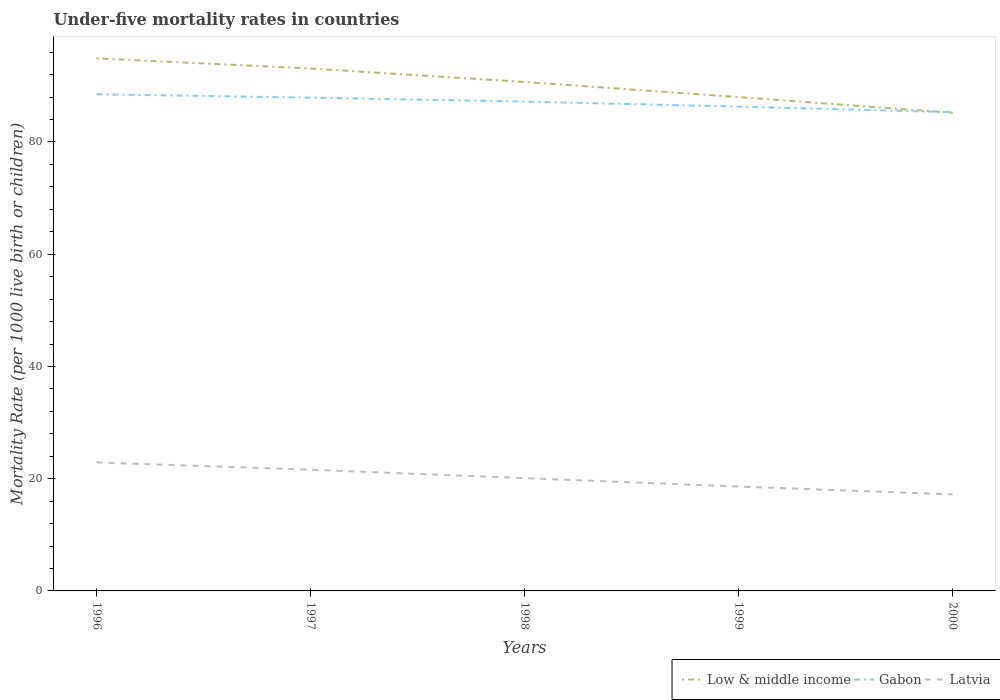Does the line corresponding to Low & middle income intersect with the line corresponding to Latvia?
Offer a terse response. No. Is the number of lines equal to the number of legend labels?
Your answer should be compact. Yes. Across all years, what is the maximum under-five mortality rate in Gabon?
Your answer should be very brief. 85.3. In which year was the under-five mortality rate in Low & middle income maximum?
Give a very brief answer. 2000. What is the total under-five mortality rate in Gabon in the graph?
Provide a short and direct response. 0.6. What is the difference between the highest and the second highest under-five mortality rate in Low & middle income?
Your answer should be compact. 9.7. What is the difference between the highest and the lowest under-five mortality rate in Gabon?
Provide a short and direct response. 3. Is the under-five mortality rate in Latvia strictly greater than the under-five mortality rate in Low & middle income over the years?
Keep it short and to the point. Yes. How many lines are there?
Your response must be concise. 3. How many years are there in the graph?
Offer a very short reply. 5. Does the graph contain any zero values?
Provide a short and direct response. No. Does the graph contain grids?
Your answer should be very brief. No. What is the title of the graph?
Your answer should be compact. Under-five mortality rates in countries. What is the label or title of the X-axis?
Make the answer very short. Years. What is the label or title of the Y-axis?
Provide a succinct answer. Mortality Rate (per 1000 live birth or children). What is the Mortality Rate (per 1000 live birth or children) of Low & middle income in 1996?
Your answer should be very brief. 94.9. What is the Mortality Rate (per 1000 live birth or children) of Gabon in 1996?
Provide a succinct answer. 88.5. What is the Mortality Rate (per 1000 live birth or children) of Latvia in 1996?
Make the answer very short. 22.9. What is the Mortality Rate (per 1000 live birth or children) in Low & middle income in 1997?
Provide a short and direct response. 93.1. What is the Mortality Rate (per 1000 live birth or children) of Gabon in 1997?
Your answer should be very brief. 87.9. What is the Mortality Rate (per 1000 live birth or children) of Latvia in 1997?
Ensure brevity in your answer.  21.6. What is the Mortality Rate (per 1000 live birth or children) of Low & middle income in 1998?
Ensure brevity in your answer.  90.7. What is the Mortality Rate (per 1000 live birth or children) in Gabon in 1998?
Offer a terse response. 87.2. What is the Mortality Rate (per 1000 live birth or children) in Latvia in 1998?
Provide a short and direct response. 20.1. What is the Mortality Rate (per 1000 live birth or children) of Gabon in 1999?
Provide a succinct answer. 86.3. What is the Mortality Rate (per 1000 live birth or children) of Latvia in 1999?
Offer a terse response. 18.6. What is the Mortality Rate (per 1000 live birth or children) of Low & middle income in 2000?
Your answer should be compact. 85.2. What is the Mortality Rate (per 1000 live birth or children) of Gabon in 2000?
Keep it short and to the point. 85.3. Across all years, what is the maximum Mortality Rate (per 1000 live birth or children) in Low & middle income?
Your answer should be compact. 94.9. Across all years, what is the maximum Mortality Rate (per 1000 live birth or children) of Gabon?
Keep it short and to the point. 88.5. Across all years, what is the maximum Mortality Rate (per 1000 live birth or children) in Latvia?
Your answer should be compact. 22.9. Across all years, what is the minimum Mortality Rate (per 1000 live birth or children) in Low & middle income?
Provide a succinct answer. 85.2. Across all years, what is the minimum Mortality Rate (per 1000 live birth or children) of Gabon?
Keep it short and to the point. 85.3. Across all years, what is the minimum Mortality Rate (per 1000 live birth or children) in Latvia?
Provide a short and direct response. 17.2. What is the total Mortality Rate (per 1000 live birth or children) of Low & middle income in the graph?
Provide a succinct answer. 451.9. What is the total Mortality Rate (per 1000 live birth or children) of Gabon in the graph?
Your answer should be very brief. 435.2. What is the total Mortality Rate (per 1000 live birth or children) of Latvia in the graph?
Your response must be concise. 100.4. What is the difference between the Mortality Rate (per 1000 live birth or children) in Low & middle income in 1996 and that in 1998?
Your response must be concise. 4.2. What is the difference between the Mortality Rate (per 1000 live birth or children) in Gabon in 1996 and that in 1998?
Offer a terse response. 1.3. What is the difference between the Mortality Rate (per 1000 live birth or children) of Low & middle income in 1996 and that in 1999?
Give a very brief answer. 6.9. What is the difference between the Mortality Rate (per 1000 live birth or children) of Gabon in 1996 and that in 1999?
Your answer should be very brief. 2.2. What is the difference between the Mortality Rate (per 1000 live birth or children) in Latvia in 1996 and that in 1999?
Your response must be concise. 4.3. What is the difference between the Mortality Rate (per 1000 live birth or children) in Low & middle income in 1996 and that in 2000?
Keep it short and to the point. 9.7. What is the difference between the Mortality Rate (per 1000 live birth or children) in Latvia in 1996 and that in 2000?
Your answer should be very brief. 5.7. What is the difference between the Mortality Rate (per 1000 live birth or children) in Low & middle income in 1997 and that in 1998?
Your answer should be compact. 2.4. What is the difference between the Mortality Rate (per 1000 live birth or children) in Gabon in 1997 and that in 1998?
Offer a very short reply. 0.7. What is the difference between the Mortality Rate (per 1000 live birth or children) in Latvia in 1997 and that in 1998?
Offer a very short reply. 1.5. What is the difference between the Mortality Rate (per 1000 live birth or children) in Latvia in 1997 and that in 1999?
Offer a very short reply. 3. What is the difference between the Mortality Rate (per 1000 live birth or children) of Gabon in 1997 and that in 2000?
Ensure brevity in your answer.  2.6. What is the difference between the Mortality Rate (per 1000 live birth or children) in Low & middle income in 1998 and that in 1999?
Provide a succinct answer. 2.7. What is the difference between the Mortality Rate (per 1000 live birth or children) of Latvia in 1998 and that in 1999?
Your response must be concise. 1.5. What is the difference between the Mortality Rate (per 1000 live birth or children) of Gabon in 1998 and that in 2000?
Make the answer very short. 1.9. What is the difference between the Mortality Rate (per 1000 live birth or children) in Latvia in 1998 and that in 2000?
Your response must be concise. 2.9. What is the difference between the Mortality Rate (per 1000 live birth or children) of Low & middle income in 1999 and that in 2000?
Your response must be concise. 2.8. What is the difference between the Mortality Rate (per 1000 live birth or children) in Latvia in 1999 and that in 2000?
Provide a succinct answer. 1.4. What is the difference between the Mortality Rate (per 1000 live birth or children) of Low & middle income in 1996 and the Mortality Rate (per 1000 live birth or children) of Latvia in 1997?
Your answer should be compact. 73.3. What is the difference between the Mortality Rate (per 1000 live birth or children) of Gabon in 1996 and the Mortality Rate (per 1000 live birth or children) of Latvia in 1997?
Ensure brevity in your answer.  66.9. What is the difference between the Mortality Rate (per 1000 live birth or children) of Low & middle income in 1996 and the Mortality Rate (per 1000 live birth or children) of Latvia in 1998?
Provide a succinct answer. 74.8. What is the difference between the Mortality Rate (per 1000 live birth or children) of Gabon in 1996 and the Mortality Rate (per 1000 live birth or children) of Latvia in 1998?
Offer a very short reply. 68.4. What is the difference between the Mortality Rate (per 1000 live birth or children) in Low & middle income in 1996 and the Mortality Rate (per 1000 live birth or children) in Gabon in 1999?
Provide a short and direct response. 8.6. What is the difference between the Mortality Rate (per 1000 live birth or children) of Low & middle income in 1996 and the Mortality Rate (per 1000 live birth or children) of Latvia in 1999?
Your answer should be very brief. 76.3. What is the difference between the Mortality Rate (per 1000 live birth or children) in Gabon in 1996 and the Mortality Rate (per 1000 live birth or children) in Latvia in 1999?
Give a very brief answer. 69.9. What is the difference between the Mortality Rate (per 1000 live birth or children) in Low & middle income in 1996 and the Mortality Rate (per 1000 live birth or children) in Gabon in 2000?
Your response must be concise. 9.6. What is the difference between the Mortality Rate (per 1000 live birth or children) in Low & middle income in 1996 and the Mortality Rate (per 1000 live birth or children) in Latvia in 2000?
Your response must be concise. 77.7. What is the difference between the Mortality Rate (per 1000 live birth or children) in Gabon in 1996 and the Mortality Rate (per 1000 live birth or children) in Latvia in 2000?
Make the answer very short. 71.3. What is the difference between the Mortality Rate (per 1000 live birth or children) of Low & middle income in 1997 and the Mortality Rate (per 1000 live birth or children) of Gabon in 1998?
Offer a terse response. 5.9. What is the difference between the Mortality Rate (per 1000 live birth or children) of Gabon in 1997 and the Mortality Rate (per 1000 live birth or children) of Latvia in 1998?
Your answer should be very brief. 67.8. What is the difference between the Mortality Rate (per 1000 live birth or children) of Low & middle income in 1997 and the Mortality Rate (per 1000 live birth or children) of Gabon in 1999?
Provide a succinct answer. 6.8. What is the difference between the Mortality Rate (per 1000 live birth or children) in Low & middle income in 1997 and the Mortality Rate (per 1000 live birth or children) in Latvia in 1999?
Give a very brief answer. 74.5. What is the difference between the Mortality Rate (per 1000 live birth or children) in Gabon in 1997 and the Mortality Rate (per 1000 live birth or children) in Latvia in 1999?
Provide a short and direct response. 69.3. What is the difference between the Mortality Rate (per 1000 live birth or children) of Low & middle income in 1997 and the Mortality Rate (per 1000 live birth or children) of Gabon in 2000?
Give a very brief answer. 7.8. What is the difference between the Mortality Rate (per 1000 live birth or children) of Low & middle income in 1997 and the Mortality Rate (per 1000 live birth or children) of Latvia in 2000?
Provide a succinct answer. 75.9. What is the difference between the Mortality Rate (per 1000 live birth or children) of Gabon in 1997 and the Mortality Rate (per 1000 live birth or children) of Latvia in 2000?
Offer a very short reply. 70.7. What is the difference between the Mortality Rate (per 1000 live birth or children) of Low & middle income in 1998 and the Mortality Rate (per 1000 live birth or children) of Latvia in 1999?
Offer a very short reply. 72.1. What is the difference between the Mortality Rate (per 1000 live birth or children) in Gabon in 1998 and the Mortality Rate (per 1000 live birth or children) in Latvia in 1999?
Your answer should be compact. 68.6. What is the difference between the Mortality Rate (per 1000 live birth or children) in Low & middle income in 1998 and the Mortality Rate (per 1000 live birth or children) in Latvia in 2000?
Your answer should be compact. 73.5. What is the difference between the Mortality Rate (per 1000 live birth or children) of Low & middle income in 1999 and the Mortality Rate (per 1000 live birth or children) of Latvia in 2000?
Ensure brevity in your answer.  70.8. What is the difference between the Mortality Rate (per 1000 live birth or children) in Gabon in 1999 and the Mortality Rate (per 1000 live birth or children) in Latvia in 2000?
Offer a terse response. 69.1. What is the average Mortality Rate (per 1000 live birth or children) of Low & middle income per year?
Provide a succinct answer. 90.38. What is the average Mortality Rate (per 1000 live birth or children) in Gabon per year?
Give a very brief answer. 87.04. What is the average Mortality Rate (per 1000 live birth or children) in Latvia per year?
Your answer should be very brief. 20.08. In the year 1996, what is the difference between the Mortality Rate (per 1000 live birth or children) in Low & middle income and Mortality Rate (per 1000 live birth or children) in Gabon?
Offer a terse response. 6.4. In the year 1996, what is the difference between the Mortality Rate (per 1000 live birth or children) in Low & middle income and Mortality Rate (per 1000 live birth or children) in Latvia?
Your answer should be very brief. 72. In the year 1996, what is the difference between the Mortality Rate (per 1000 live birth or children) of Gabon and Mortality Rate (per 1000 live birth or children) of Latvia?
Provide a succinct answer. 65.6. In the year 1997, what is the difference between the Mortality Rate (per 1000 live birth or children) of Low & middle income and Mortality Rate (per 1000 live birth or children) of Latvia?
Offer a very short reply. 71.5. In the year 1997, what is the difference between the Mortality Rate (per 1000 live birth or children) of Gabon and Mortality Rate (per 1000 live birth or children) of Latvia?
Give a very brief answer. 66.3. In the year 1998, what is the difference between the Mortality Rate (per 1000 live birth or children) in Low & middle income and Mortality Rate (per 1000 live birth or children) in Gabon?
Offer a very short reply. 3.5. In the year 1998, what is the difference between the Mortality Rate (per 1000 live birth or children) in Low & middle income and Mortality Rate (per 1000 live birth or children) in Latvia?
Give a very brief answer. 70.6. In the year 1998, what is the difference between the Mortality Rate (per 1000 live birth or children) of Gabon and Mortality Rate (per 1000 live birth or children) of Latvia?
Your answer should be very brief. 67.1. In the year 1999, what is the difference between the Mortality Rate (per 1000 live birth or children) in Low & middle income and Mortality Rate (per 1000 live birth or children) in Gabon?
Offer a terse response. 1.7. In the year 1999, what is the difference between the Mortality Rate (per 1000 live birth or children) in Low & middle income and Mortality Rate (per 1000 live birth or children) in Latvia?
Your answer should be very brief. 69.4. In the year 1999, what is the difference between the Mortality Rate (per 1000 live birth or children) in Gabon and Mortality Rate (per 1000 live birth or children) in Latvia?
Provide a succinct answer. 67.7. In the year 2000, what is the difference between the Mortality Rate (per 1000 live birth or children) of Low & middle income and Mortality Rate (per 1000 live birth or children) of Gabon?
Offer a very short reply. -0.1. In the year 2000, what is the difference between the Mortality Rate (per 1000 live birth or children) in Low & middle income and Mortality Rate (per 1000 live birth or children) in Latvia?
Your answer should be very brief. 68. In the year 2000, what is the difference between the Mortality Rate (per 1000 live birth or children) in Gabon and Mortality Rate (per 1000 live birth or children) in Latvia?
Your answer should be very brief. 68.1. What is the ratio of the Mortality Rate (per 1000 live birth or children) in Low & middle income in 1996 to that in 1997?
Provide a short and direct response. 1.02. What is the ratio of the Mortality Rate (per 1000 live birth or children) of Gabon in 1996 to that in 1997?
Make the answer very short. 1.01. What is the ratio of the Mortality Rate (per 1000 live birth or children) of Latvia in 1996 to that in 1997?
Provide a succinct answer. 1.06. What is the ratio of the Mortality Rate (per 1000 live birth or children) of Low & middle income in 1996 to that in 1998?
Your response must be concise. 1.05. What is the ratio of the Mortality Rate (per 1000 live birth or children) in Gabon in 1996 to that in 1998?
Your answer should be compact. 1.01. What is the ratio of the Mortality Rate (per 1000 live birth or children) of Latvia in 1996 to that in 1998?
Give a very brief answer. 1.14. What is the ratio of the Mortality Rate (per 1000 live birth or children) in Low & middle income in 1996 to that in 1999?
Your answer should be very brief. 1.08. What is the ratio of the Mortality Rate (per 1000 live birth or children) of Gabon in 1996 to that in 1999?
Keep it short and to the point. 1.03. What is the ratio of the Mortality Rate (per 1000 live birth or children) in Latvia in 1996 to that in 1999?
Keep it short and to the point. 1.23. What is the ratio of the Mortality Rate (per 1000 live birth or children) in Low & middle income in 1996 to that in 2000?
Ensure brevity in your answer.  1.11. What is the ratio of the Mortality Rate (per 1000 live birth or children) of Gabon in 1996 to that in 2000?
Your response must be concise. 1.04. What is the ratio of the Mortality Rate (per 1000 live birth or children) of Latvia in 1996 to that in 2000?
Offer a very short reply. 1.33. What is the ratio of the Mortality Rate (per 1000 live birth or children) of Low & middle income in 1997 to that in 1998?
Offer a terse response. 1.03. What is the ratio of the Mortality Rate (per 1000 live birth or children) in Latvia in 1997 to that in 1998?
Ensure brevity in your answer.  1.07. What is the ratio of the Mortality Rate (per 1000 live birth or children) in Low & middle income in 1997 to that in 1999?
Your response must be concise. 1.06. What is the ratio of the Mortality Rate (per 1000 live birth or children) in Gabon in 1997 to that in 1999?
Make the answer very short. 1.02. What is the ratio of the Mortality Rate (per 1000 live birth or children) of Latvia in 1997 to that in 1999?
Your answer should be compact. 1.16. What is the ratio of the Mortality Rate (per 1000 live birth or children) in Low & middle income in 1997 to that in 2000?
Your response must be concise. 1.09. What is the ratio of the Mortality Rate (per 1000 live birth or children) of Gabon in 1997 to that in 2000?
Give a very brief answer. 1.03. What is the ratio of the Mortality Rate (per 1000 live birth or children) of Latvia in 1997 to that in 2000?
Provide a succinct answer. 1.26. What is the ratio of the Mortality Rate (per 1000 live birth or children) of Low & middle income in 1998 to that in 1999?
Offer a terse response. 1.03. What is the ratio of the Mortality Rate (per 1000 live birth or children) in Gabon in 1998 to that in 1999?
Give a very brief answer. 1.01. What is the ratio of the Mortality Rate (per 1000 live birth or children) of Latvia in 1998 to that in 1999?
Your answer should be compact. 1.08. What is the ratio of the Mortality Rate (per 1000 live birth or children) of Low & middle income in 1998 to that in 2000?
Provide a short and direct response. 1.06. What is the ratio of the Mortality Rate (per 1000 live birth or children) of Gabon in 1998 to that in 2000?
Your answer should be very brief. 1.02. What is the ratio of the Mortality Rate (per 1000 live birth or children) in Latvia in 1998 to that in 2000?
Ensure brevity in your answer.  1.17. What is the ratio of the Mortality Rate (per 1000 live birth or children) in Low & middle income in 1999 to that in 2000?
Make the answer very short. 1.03. What is the ratio of the Mortality Rate (per 1000 live birth or children) of Gabon in 1999 to that in 2000?
Make the answer very short. 1.01. What is the ratio of the Mortality Rate (per 1000 live birth or children) in Latvia in 1999 to that in 2000?
Keep it short and to the point. 1.08. What is the difference between the highest and the second highest Mortality Rate (per 1000 live birth or children) of Low & middle income?
Offer a very short reply. 1.8. What is the difference between the highest and the second highest Mortality Rate (per 1000 live birth or children) of Gabon?
Give a very brief answer. 0.6. What is the difference between the highest and the second highest Mortality Rate (per 1000 live birth or children) in Latvia?
Provide a succinct answer. 1.3. What is the difference between the highest and the lowest Mortality Rate (per 1000 live birth or children) in Low & middle income?
Your answer should be compact. 9.7. 